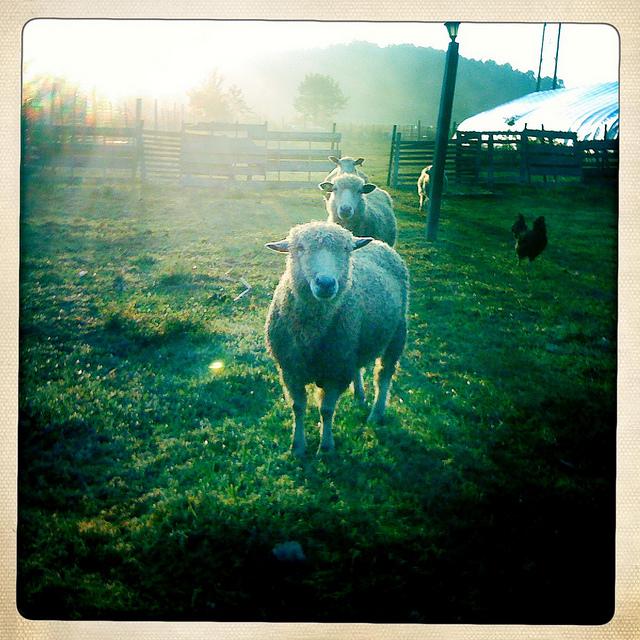Is there a greenhouse in this picture?
Give a very brief answer. Yes. How old are these sheep?
Answer briefly. Adults. How many chickens are there?
Give a very brief answer. 1. 